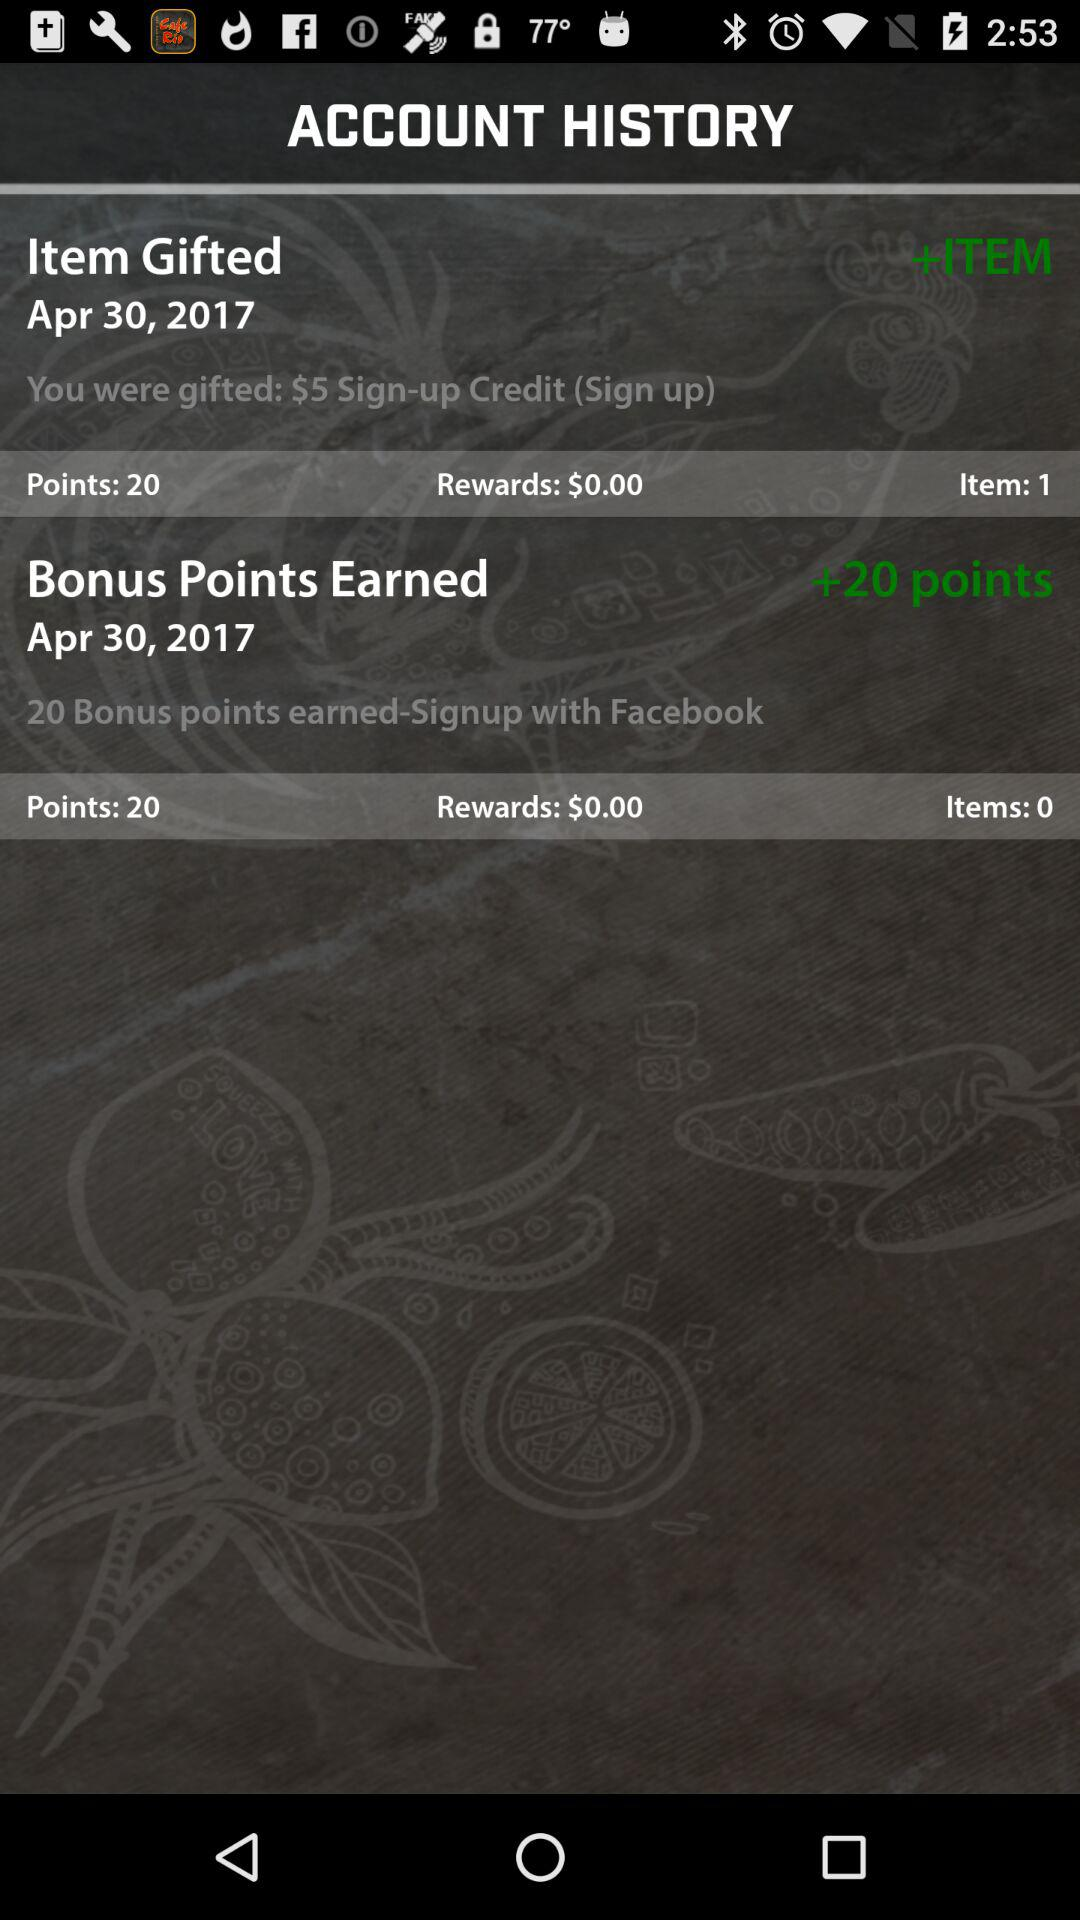Through what account can we earn 20 points for signing up? The account through which you can sign up is Facebook. 